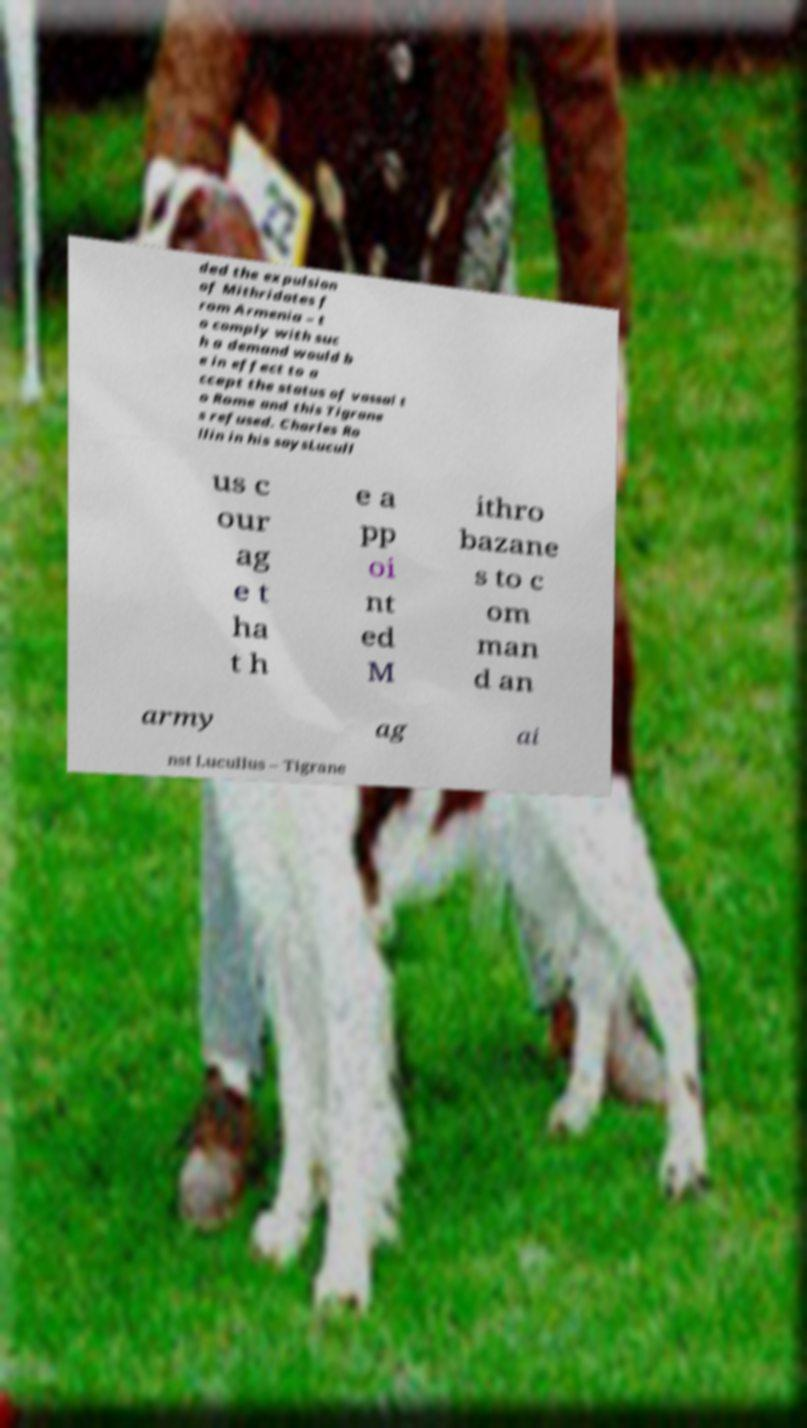There's text embedded in this image that I need extracted. Can you transcribe it verbatim? ded the expulsion of Mithridates f rom Armenia – t o comply with suc h a demand would b e in effect to a ccept the status of vassal t o Rome and this Tigrane s refused. Charles Ro llin in his saysLucull us c our ag e t ha t h e a pp oi nt ed M ithro bazane s to c om man d an army ag ai nst Lucullus – Tigrane 